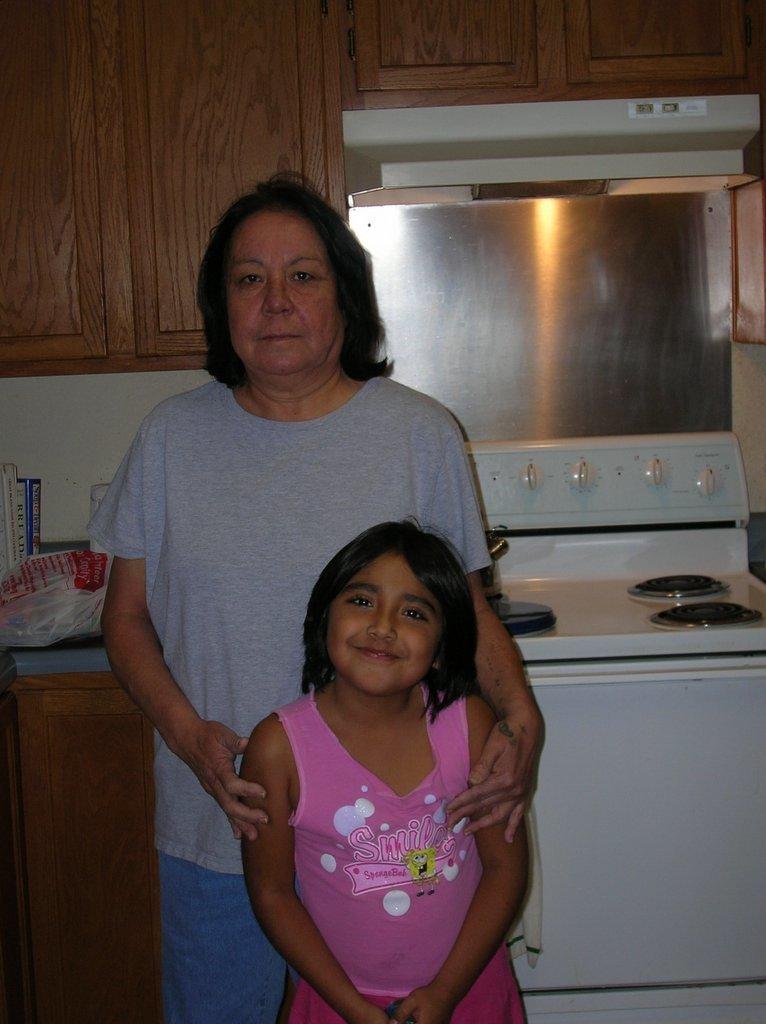What does the girls shirt say to do?
Make the answer very short. Smile. 